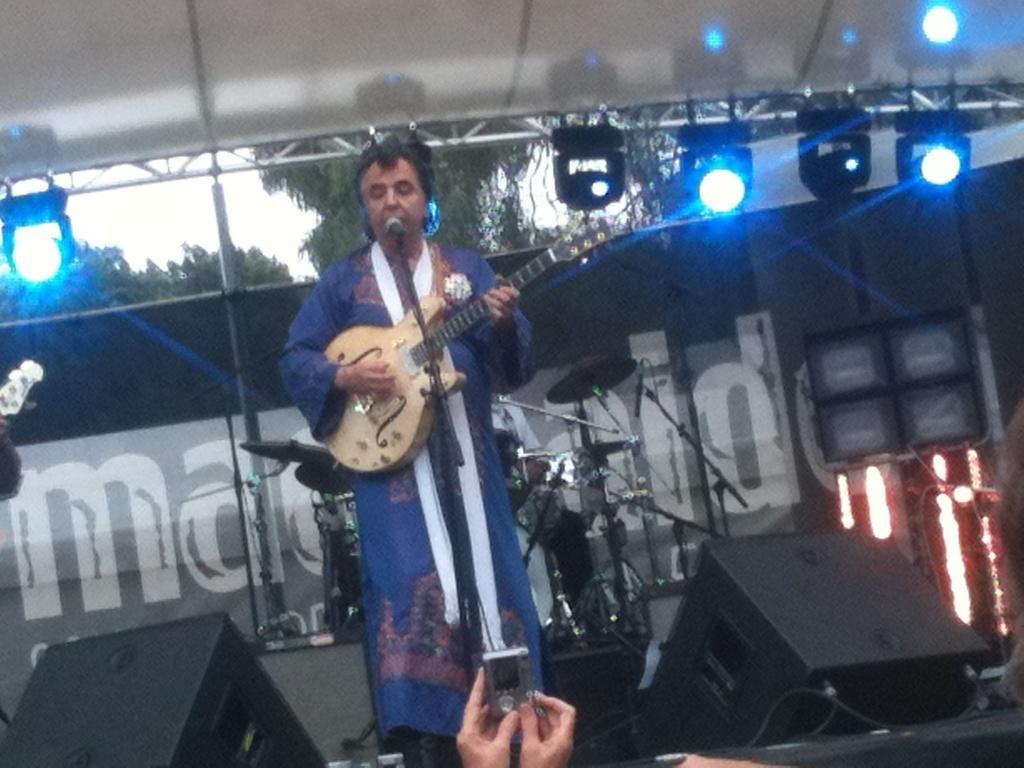Please provide a concise description of this image. A man is on the stage singing on mic and playing guitar,behind him there are musical instruments,lights,trees and sky. And a person in front of him is capturing photos. 